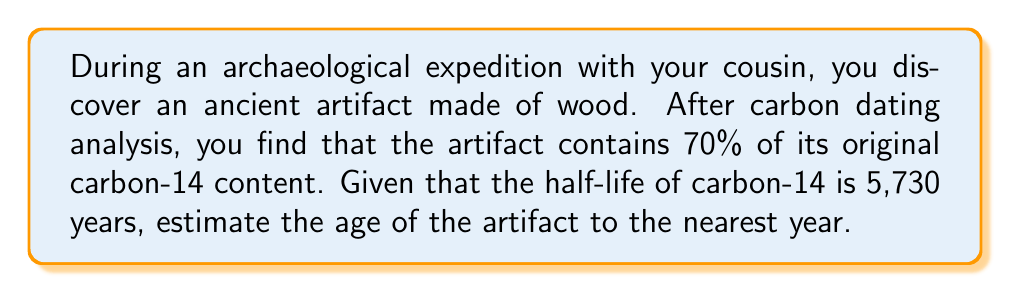Show me your answer to this math problem. To solve this problem, we'll use the radioactive decay formula and logarithmic calculations.

1) The general formula for radioactive decay is:

   $$N(t) = N_0 \cdot (1/2)^{t/t_{1/2}}$$

   Where:
   $N(t)$ is the amount remaining after time $t$
   $N_0$ is the initial amount
   $t$ is the time elapsed
   $t_{1/2}$ is the half-life

2) In this case, we know:
   $N(t)/N_0 = 0.70$ (70% remaining)
   $t_{1/2} = 5,730$ years

3) Substituting into the formula:

   $$0.70 = (1/2)^{t/5730}$$

4) To solve for $t$, we need to use logarithms. Taking the natural log of both sides:

   $$\ln(0.70) = \ln((1/2)^{t/5730})$$

5) Using the logarithm property $\ln(a^b) = b\ln(a)$:

   $$\ln(0.70) = (t/5730) \cdot \ln(1/2)$$

6) Solving for $t$:

   $$t = 5730 \cdot \frac{\ln(0.70)}{\ln(1/2)}$$

7) Calculate:
   $$t = 5730 \cdot \frac{-0.35667494}{-0.69314718} \approx 2945.7$$

8) Rounding to the nearest year:

   $$t \approx 2,946 \text{ years}$$
Answer: 2,946 years 